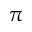<formula> <loc_0><loc_0><loc_500><loc_500>\pi</formula> 